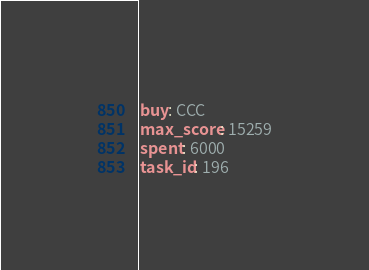<code> <loc_0><loc_0><loc_500><loc_500><_YAML_>buy: CCC
max_score: 15259
spent: 6000
task_id: 196</code> 